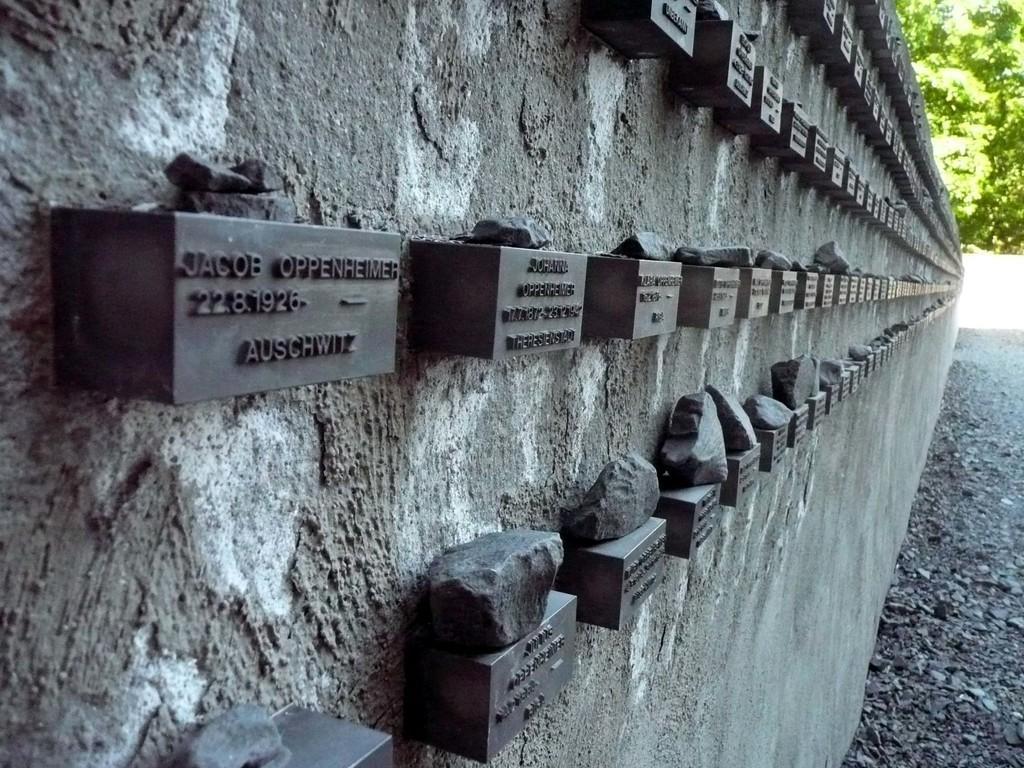In one or two sentences, can you explain what this image depicts? This image is taken outdoors. On the left side of the image there is a wall with many bricks and text on them. On the right side of the image there are a few trees. 